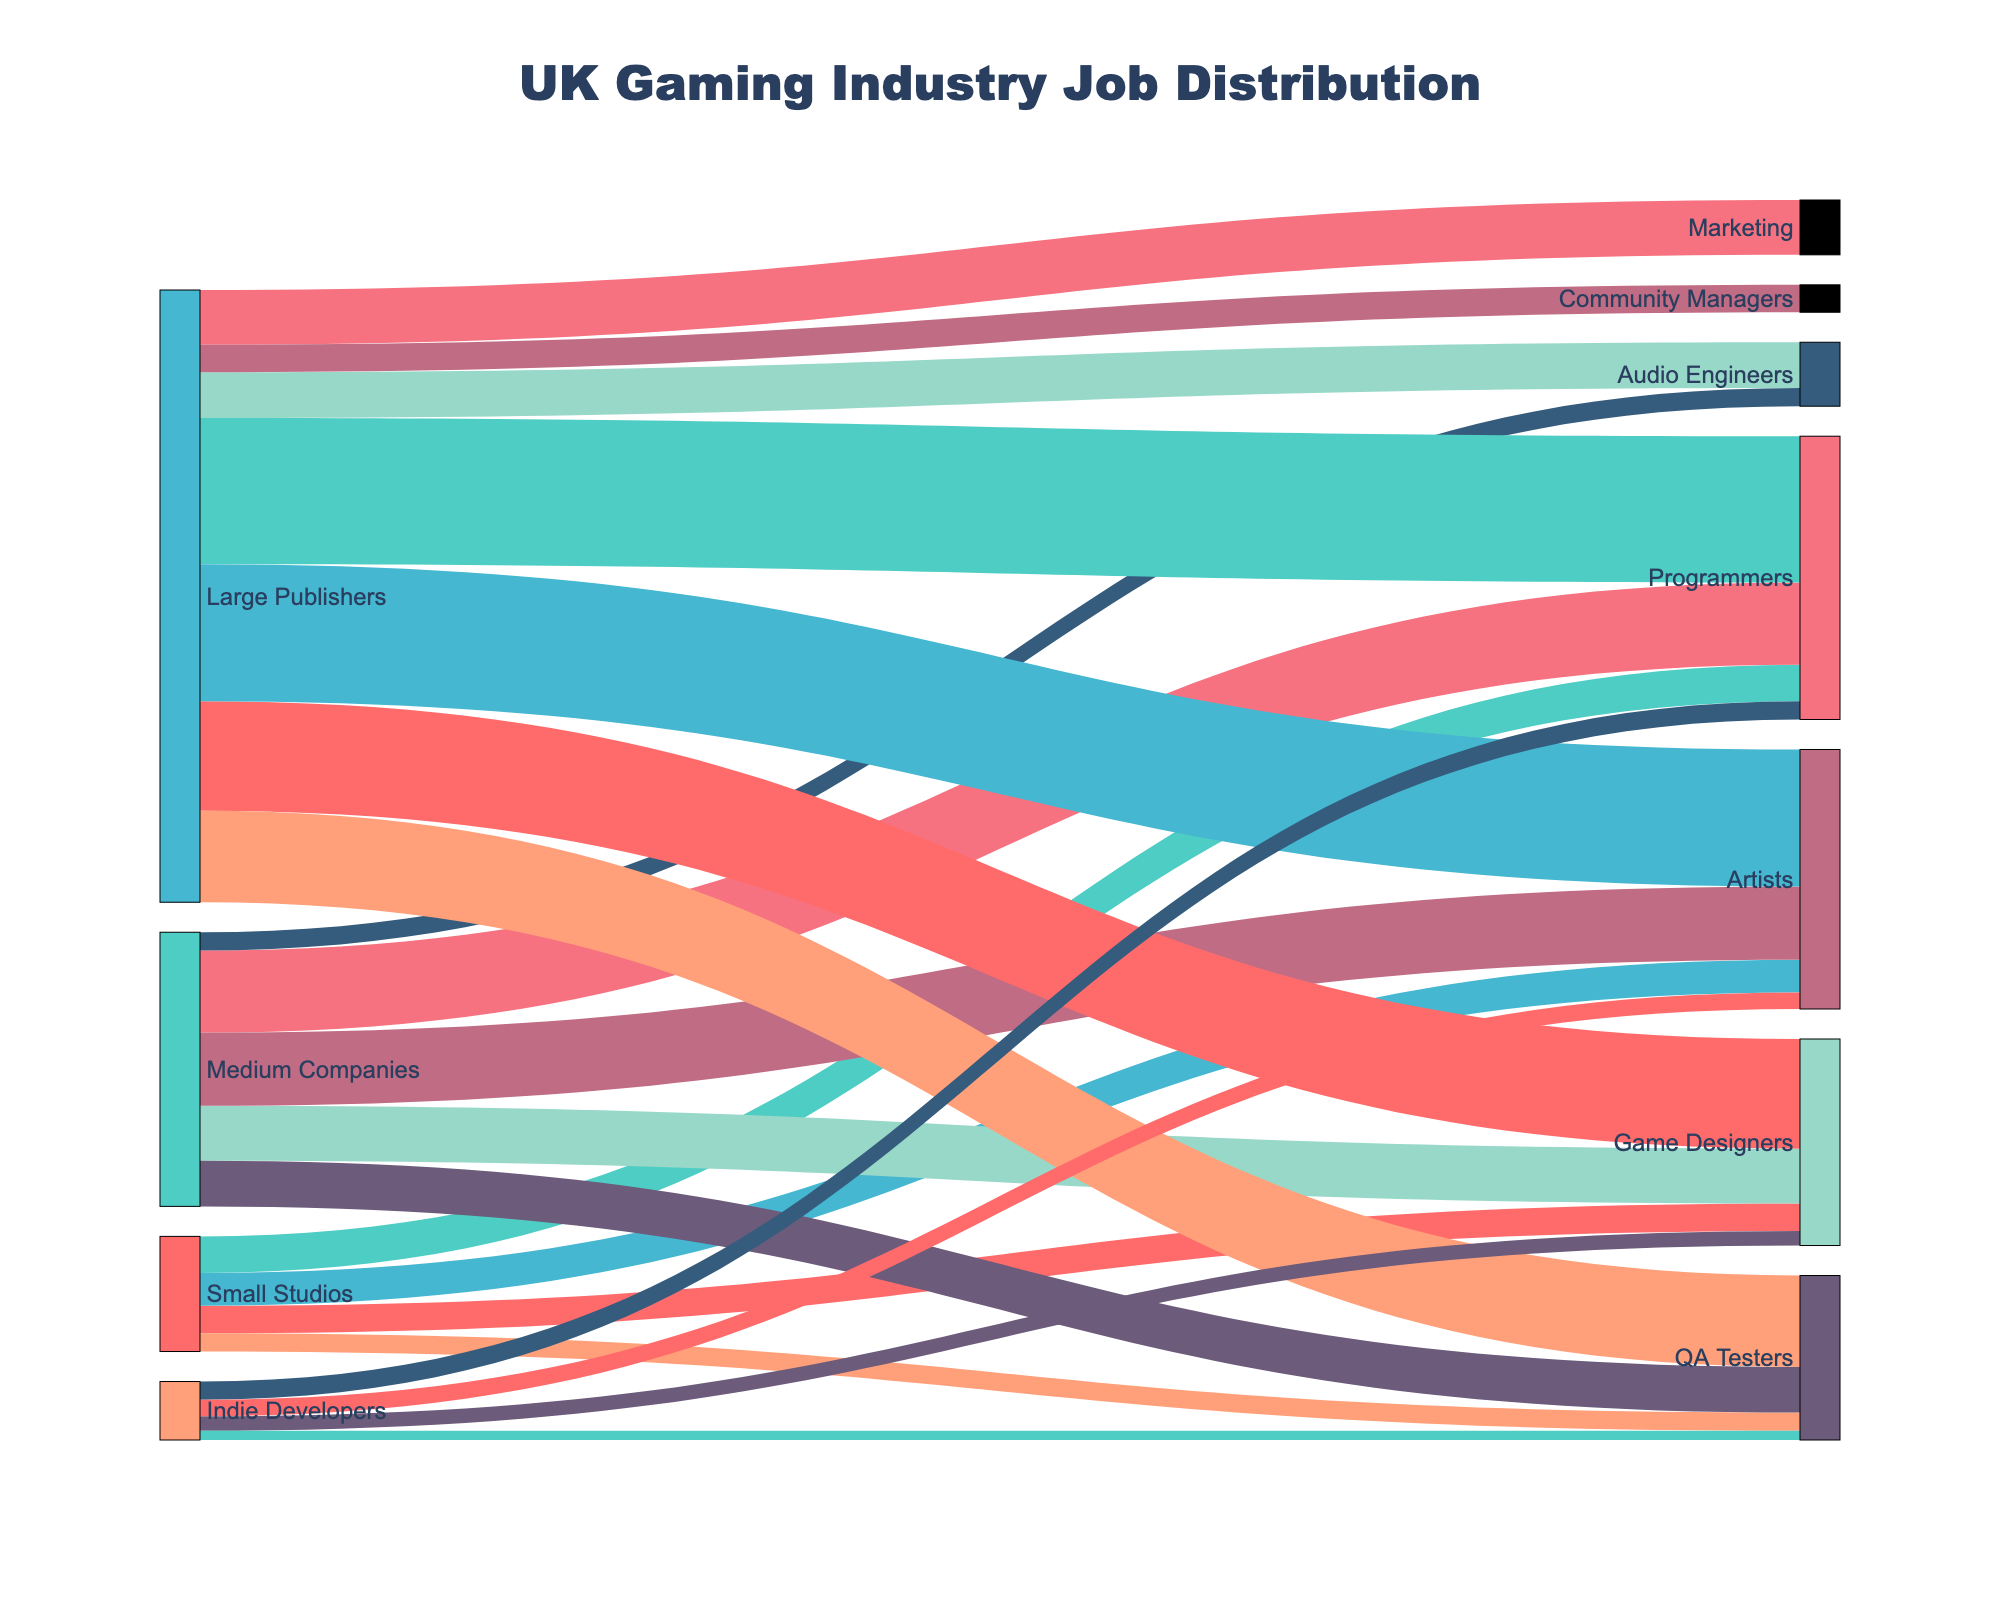What is the title of the Sankey Diagram? The title of the diagram is displayed at the top, giving a clear indication of what the visual represents.
Answer: UK Gaming Industry Job Distribution How many types of roles are represented in the diagram? By counting the unique roles listed as targets in the diagram, we can determine the number of different job roles presented.
Answer: 7 Which company type has the highest number of Game Designers? By following the flow lines from each company type to the Game Designers node, we can see the values and identify the one with the highest.
Answer: Large Publishers What is the total number of QA Testers across all company types? Add the values from all the QA Testers flows from Small Studios, Medium Companies, Large Publishers, and Indie Developers.
Answer: 900 Which role does Small Studios hire the most? By examining the value of flows from Small Studios to each role, we select the one with the highest value.
Answer: Programmers Compare the number of Programmers between Medium Companies and Large Publishers. Look at the values of flows from Medium Companies and Large Publishers to Programmers, then compare them.
Answer: Large Publishers have more How many roles does Large Publishers employ that are not present in Small Studios? Identify roles that have flows from Large Publishers but not from Small Studios, then count these roles.
Answer: 3 What is the difference in the number of Artists between Medium Companies and Indie Developers? Subtract the number of Artists in Indie Developers from that in Medium Companies.
Answer: 310 Which company type employs the least number of Game Designers? Follow the flow lines from all company types to Game Designers and identify the one with the smallest value.
Answer: Indie Developers How many total employees are represented in the diagram? Sum all the values from all flows to get the total number of employees.
Answer: 5250 